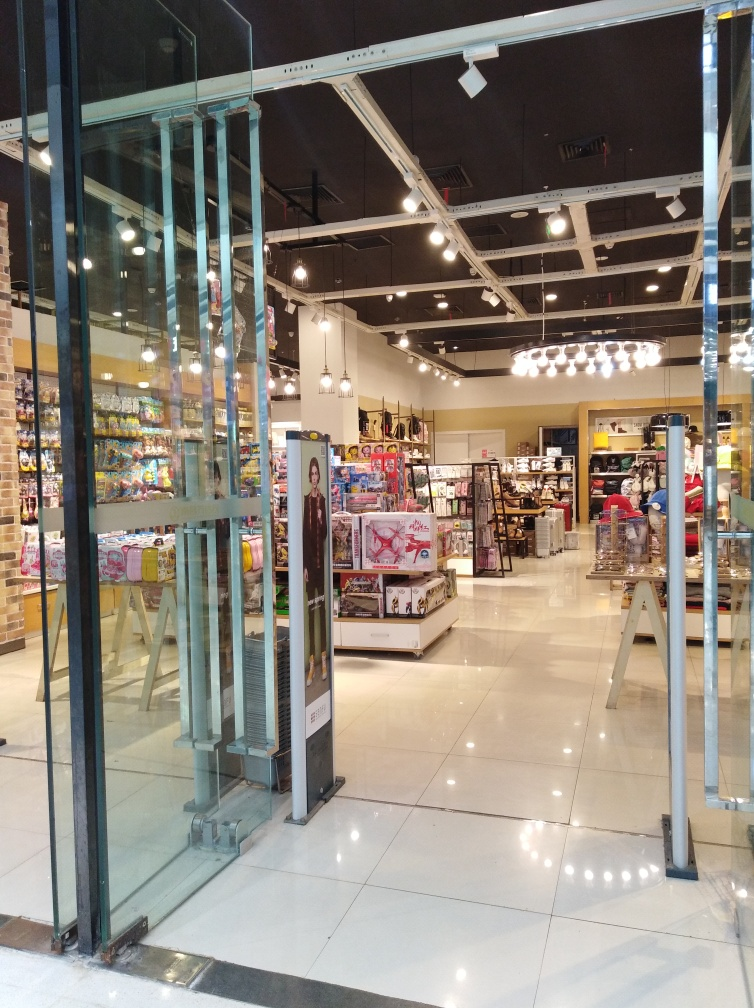What is the overall quality of the image? The image is of average quality in terms of resolution and clarity. The lighting inside the shop is well-distributed, which contributes to the visibility of the items on display. There seems to be no motion blur, suggesting the camera was steady at the time of the shot. However, the overall composition could be more engaging by focusing on specific items or areas within the store to create a visual narrative or highlight particular merchandise. 